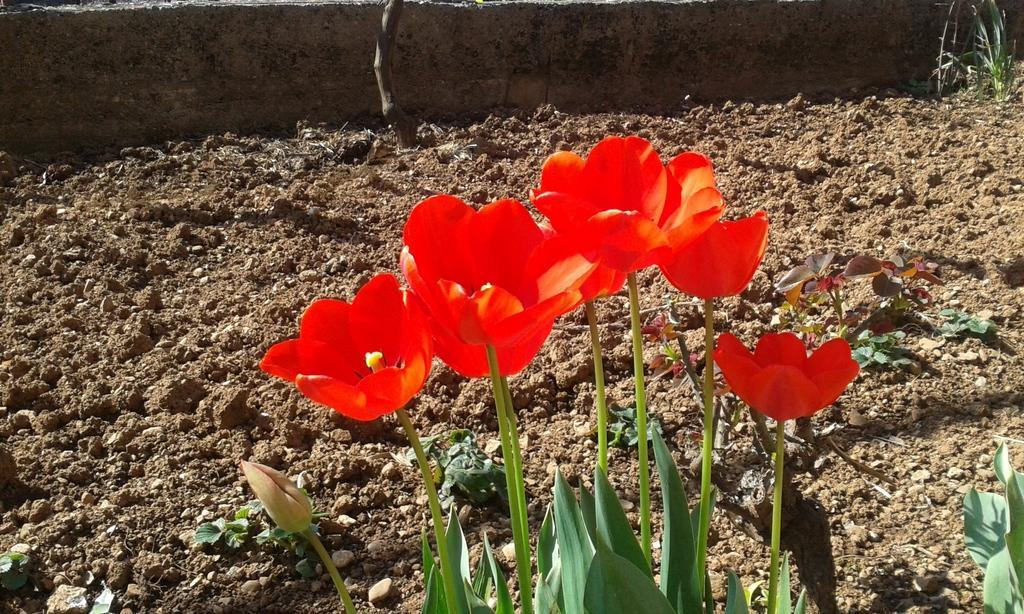Could you give a brief overview of what you see in this image? In this image in front there are plants and flowers. At the bottom of the image there is a mud. In the background of the image there is a wall. 